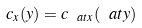<formula> <loc_0><loc_0><loc_500><loc_500>c _ { x } ( y ) = c _ { \ a t x } ( \ a t y )</formula> 